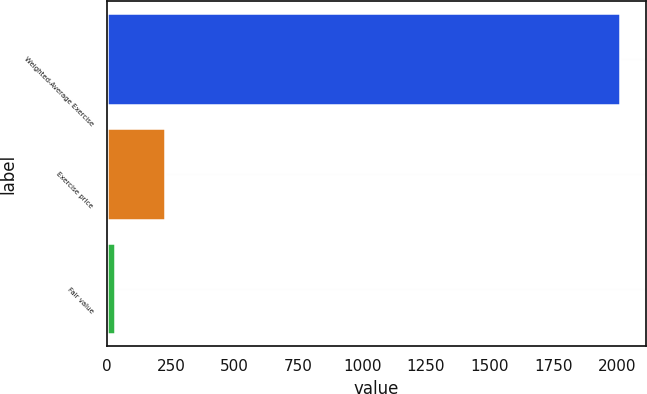Convert chart to OTSL. <chart><loc_0><loc_0><loc_500><loc_500><bar_chart><fcel>Weighted-Average Exercise<fcel>Exercise price<fcel>Fair value<nl><fcel>2011<fcel>227.8<fcel>29.67<nl></chart> 